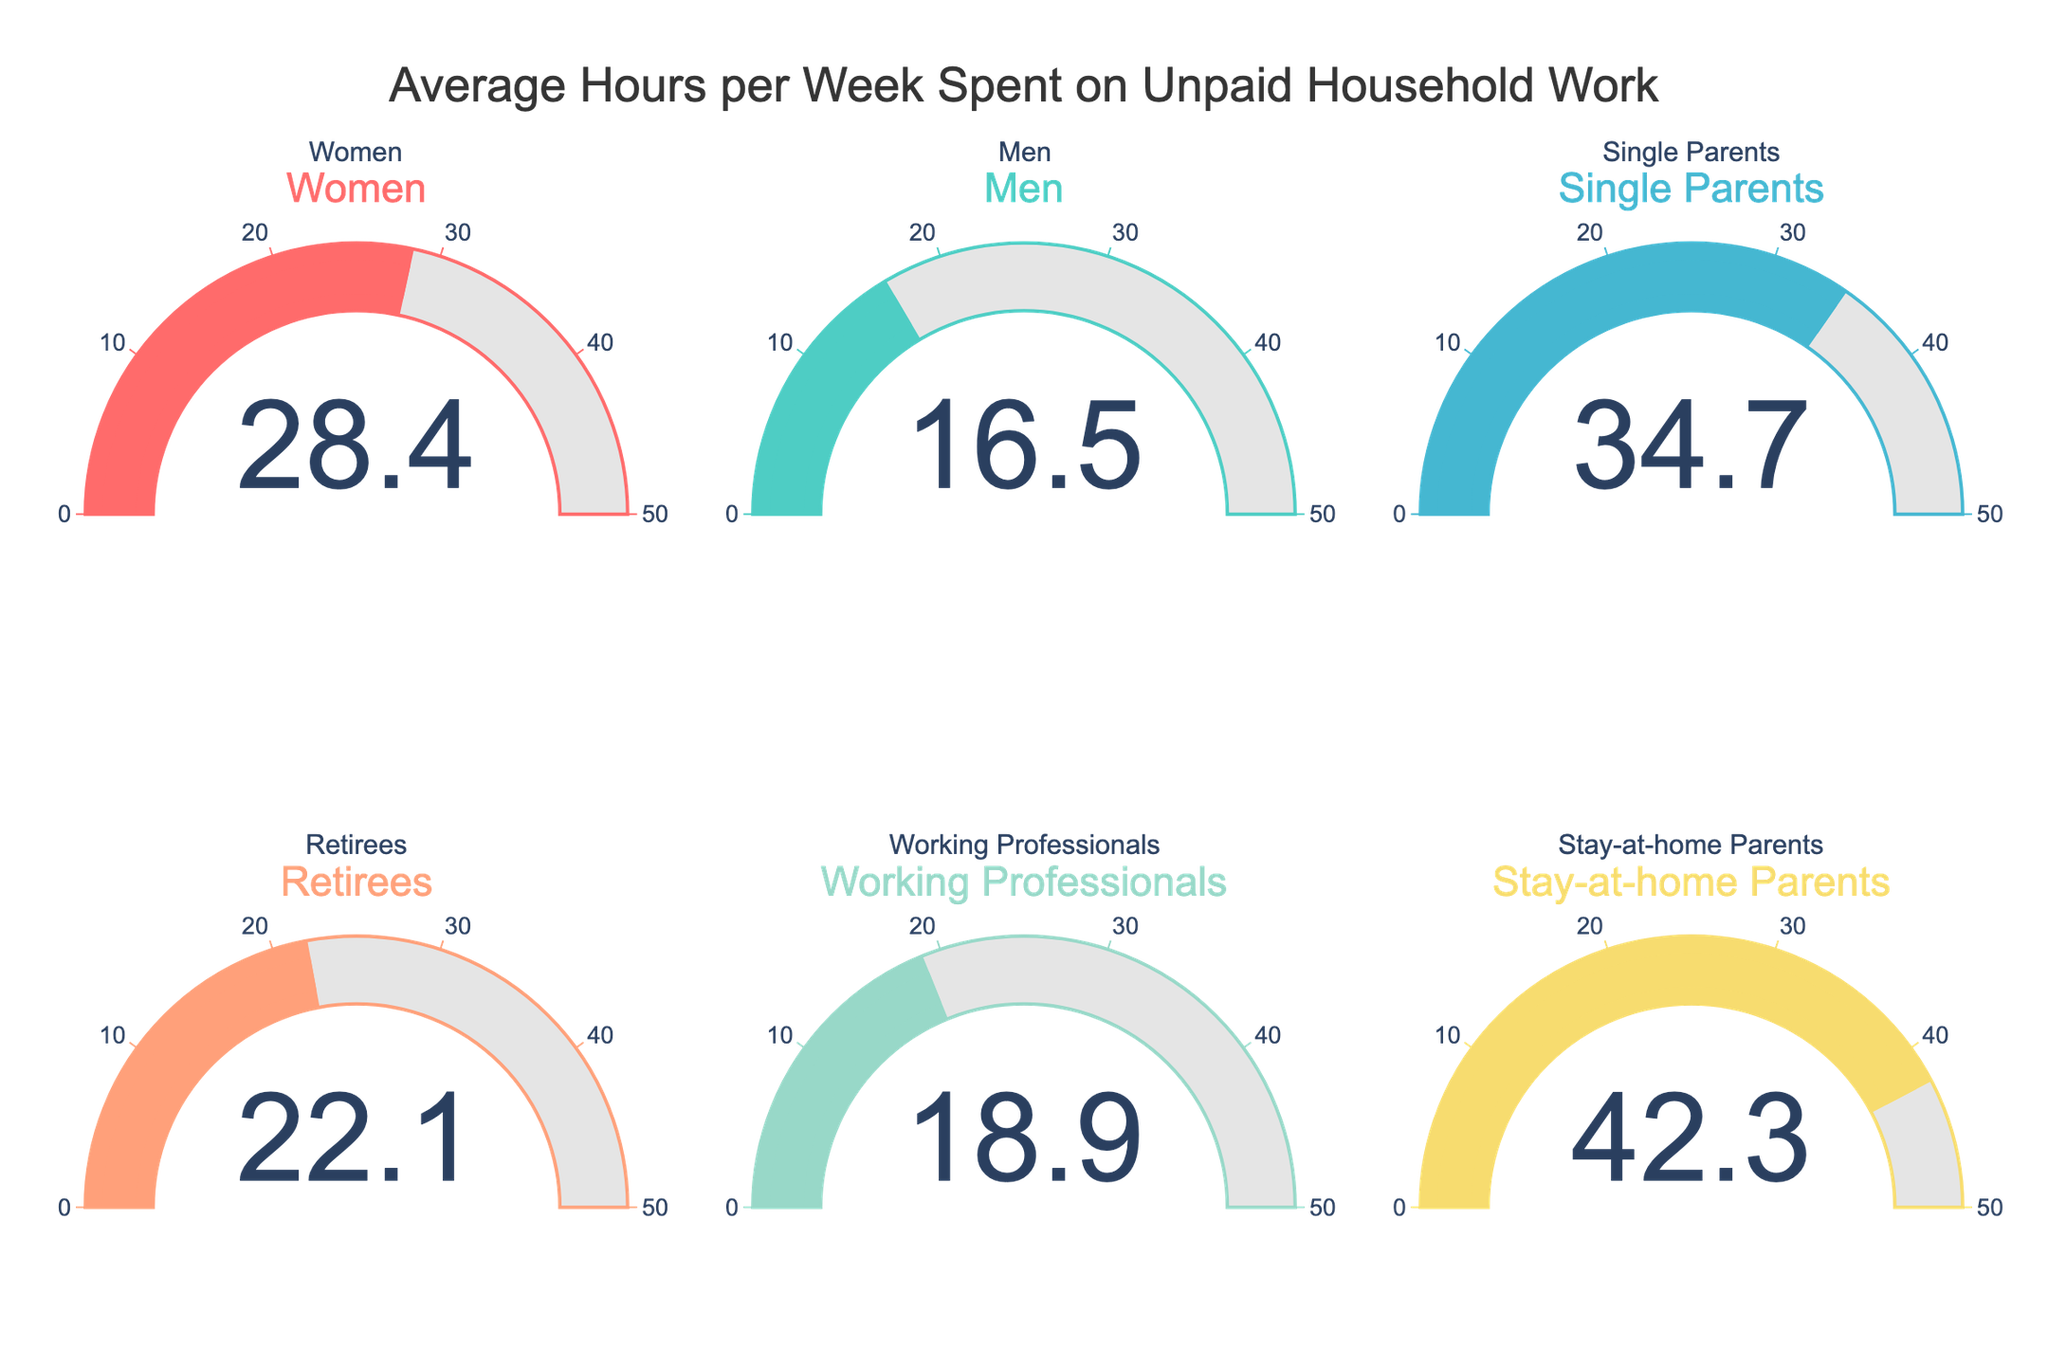What is the title of the chart? The title is located at the top center of the chart, describing its general content. It reads "Average Hours per Week Spent on Unpaid Household Work".
Answer: Average Hours per Week Spent on Unpaid Household Work How many categories are displayed in the figure? By counting the different gauge charts in the figure, we can determine the number of categories. There are six categories displayed.
Answer: Six Which category spends the most hours per week on unpaid household work? By comparing the values of each gauge chart, the highest value can be identified. The Stay-at-home Parents category has the highest value at 42.3 hours.
Answer: Stay-at-home Parents What is the average number of hours spent per week on unpaid household work across all categories? Sum the values of all categories: 28.4 (Women) + 16.5 (Men) + 34.7 (Single Parents) + 22.1 (Retirees) + 18.9 (Working Professionals) + 42.3 (Stay-at-home Parents) = 162.9. Divide by the number of categories: 162.9 / 6 = 27.15.
Answer: 27.15 How many more hours per week do Stay-at-home Parents spend on unpaid household work compared to Men? Subtract the number of hours Men spend from the number of hours Stay-at-home Parents spend: 42.3 (Stay-at-home Parents) - 16.5 (Men) = 25.8.
Answer: 25.8 Which category spends the least amount of time on unpaid household work? By comparing the values of each gauge chart, the lowest value can be identified. The Men category spends the least amount of time at 16.5 hours.
Answer: Men Is the amount of time spent by Retirees on unpaid household work greater or less than the amount spent by Working Professionals? Compare the values of these two categories: Retirees spend 22.1 hours, and Working Professionals spend 18.9 hours. 22.1 is greater than 18.9.
Answer: Greater What is the range of hours spent on unpaid household work among all categories? Subtract the minimum value from the maximum value: 42.3 (Stay-at-home Parents) - 16.5 (Men) = 25.8.
Answer: 25.8 Do Women or Single Parents spend more hours per week on unpaid household work, and by how many hours? Compare the numbers: Single Parents spend 34.7 hours, and Women spend 28.4 hours. Subtract the smaller number from the larger number: 34.7 - 28.4 = 6.3.
Answer: Single Parents by 6.3 Are there any categories with a value over 40 hours per week? Look at the values shown on the gauge charts: only the Stay-at-home Parents category has a value over 40 hours, specifically 42.3 hours.
Answer: Yes 